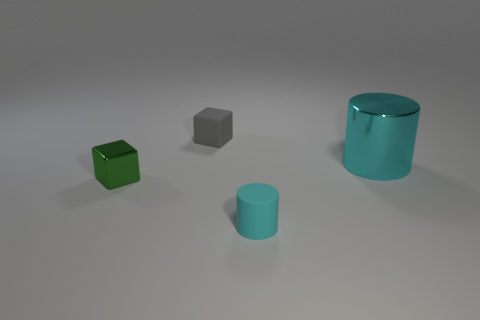Add 3 large yellow shiny cubes. How many objects exist? 7 Subtract all gray blocks. How many blocks are left? 1 Add 1 small gray shiny cylinders. How many small gray shiny cylinders exist? 1 Subtract 0 gray cylinders. How many objects are left? 4 Subtract 2 blocks. How many blocks are left? 0 Subtract all green blocks. Subtract all red cylinders. How many blocks are left? 1 Subtract all gray spheres. How many cyan cubes are left? 0 Subtract all cyan cylinders. Subtract all cyan matte objects. How many objects are left? 1 Add 4 tiny gray rubber cubes. How many tiny gray rubber cubes are left? 5 